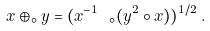Convert formula to latex. <formula><loc_0><loc_0><loc_500><loc_500>x \oplus _ { \circ } y = ( x ^ { - 1 } \ _ { \circ } ( y ^ { 2 } \circ x ) ) ^ { 1 / 2 } \, .</formula> 